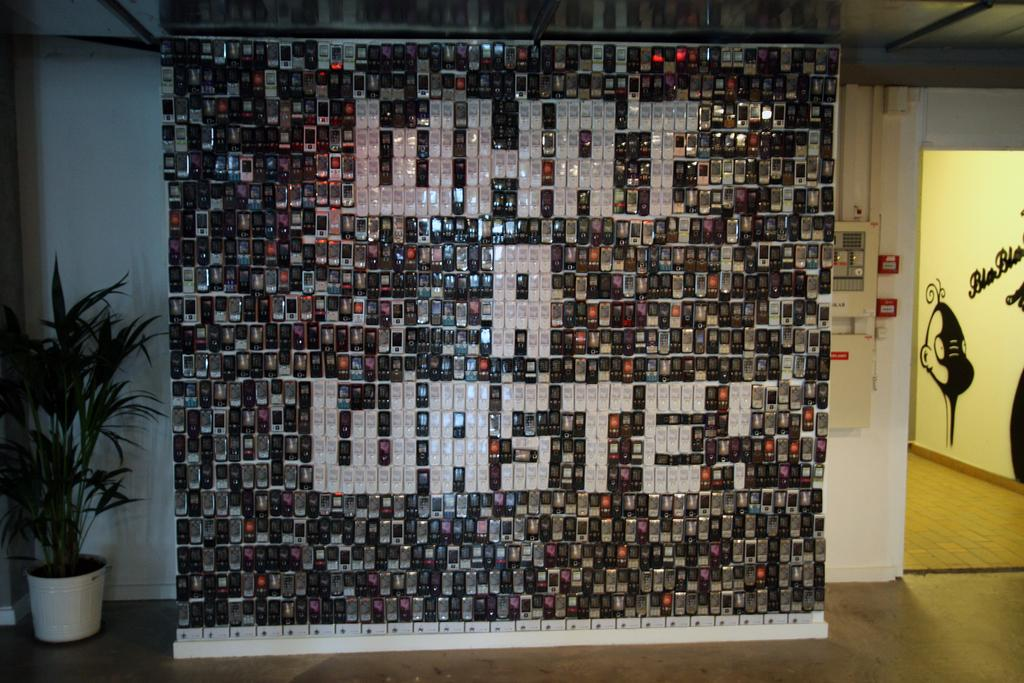<image>
Provide a brief description of the given image. A wall display of used cell phones with the phrase "What A Waste". 